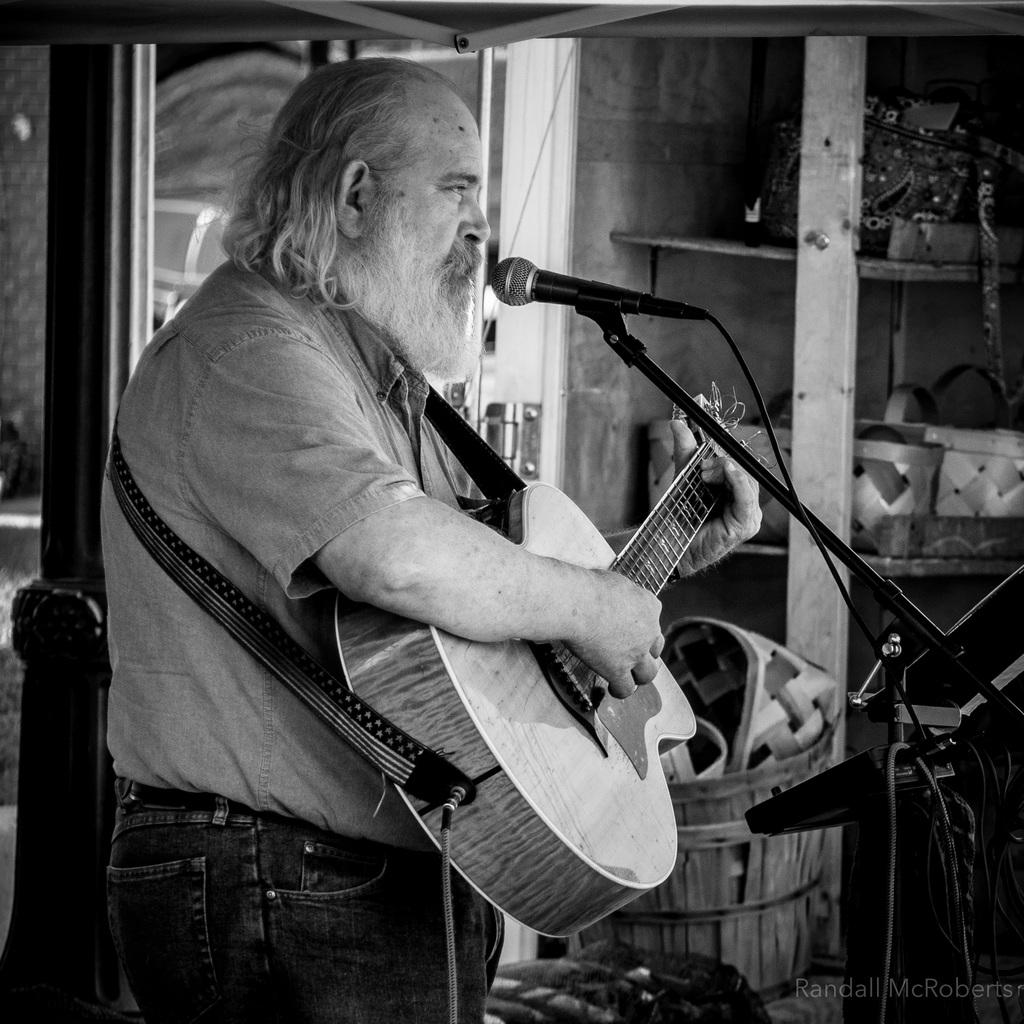What is the man in the image doing? The man is playing the guitar and singing on a microphone. What instrument is the man holding in the image? The man is holding a guitar in the image. What can be seen in the background of the image? There is a window, a rack, and baskets in the background of the image. What type of battle is taking place in the image? There is no battle present in the image; it features a man playing a guitar and singing on a microphone. Can you describe the kick performed by the man in the image? There is no kick performed by the man in the image; he is playing a guitar and singing on a microphone. 